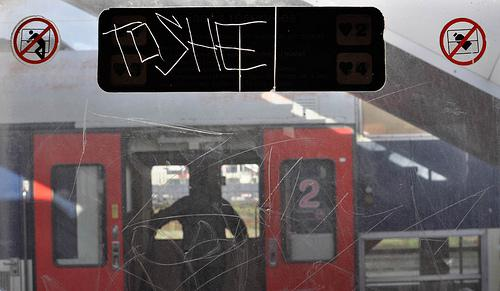Question: what color are the doors?
Choices:
A. Blue.
B. White.
C. Black.
D. Red.
Answer with the letter. Answer: D Question: who is looking outdoors?
Choices:
A. The dog.
B. The cat.
C. The bird.
D. The person.
Answer with the letter. Answer: D Question: where can a number be seen?
Choices:
A. On the television.
B. On the cell phone.
C. In the window.
D. On the sign.
Answer with the letter. Answer: C 